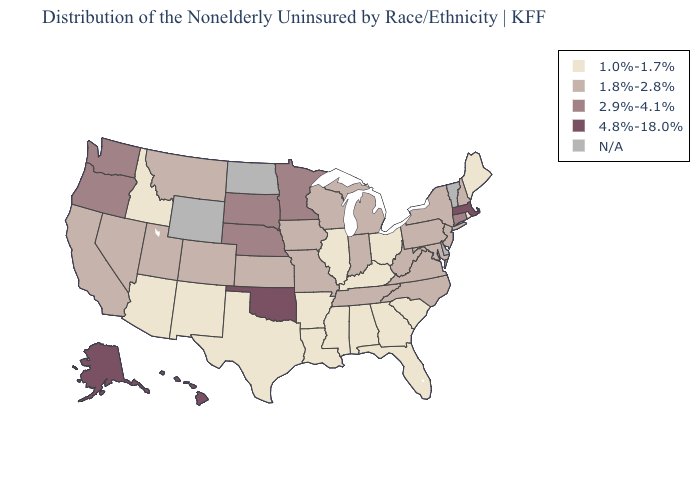What is the highest value in the MidWest ?
Keep it brief. 2.9%-4.1%. What is the lowest value in the USA?
Concise answer only. 1.0%-1.7%. Name the states that have a value in the range 4.8%-18.0%?
Give a very brief answer. Alaska, Hawaii, Massachusetts, Oklahoma. Name the states that have a value in the range 1.8%-2.8%?
Answer briefly. California, Colorado, Indiana, Iowa, Kansas, Maryland, Michigan, Missouri, Montana, Nevada, New Hampshire, New Jersey, New York, North Carolina, Pennsylvania, Tennessee, Utah, Virginia, West Virginia, Wisconsin. What is the lowest value in the Northeast?
Concise answer only. 1.0%-1.7%. What is the value of North Carolina?
Give a very brief answer. 1.8%-2.8%. What is the value of Indiana?
Concise answer only. 1.8%-2.8%. Does the first symbol in the legend represent the smallest category?
Quick response, please. Yes. Does the map have missing data?
Be succinct. Yes. Name the states that have a value in the range 2.9%-4.1%?
Keep it brief. Connecticut, Minnesota, Nebraska, Oregon, South Dakota, Washington. Which states hav the highest value in the West?
Answer briefly. Alaska, Hawaii. How many symbols are there in the legend?
Give a very brief answer. 5. Name the states that have a value in the range 2.9%-4.1%?
Short answer required. Connecticut, Minnesota, Nebraska, Oregon, South Dakota, Washington. What is the value of Kentucky?
Write a very short answer. 1.0%-1.7%. Does Arkansas have the lowest value in the South?
Short answer required. Yes. 